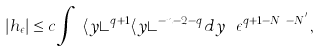<formula> <loc_0><loc_0><loc_500><loc_500>| h _ { \epsilon } | \leq c \int _ { \mathbb { R } ^ { n } } \langle y \rangle ^ { q + 1 } \langle y \rangle ^ { - n - 2 - q } d y \ \epsilon ^ { q + 1 - N _ { u } - N ^ { ^ { \prime } } } ,</formula> 